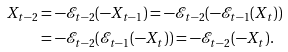Convert formula to latex. <formula><loc_0><loc_0><loc_500><loc_500>X _ { t - 2 } & = - \mathcal { E } _ { t - 2 } ( - X _ { t - 1 } ) = - \mathcal { E } _ { t - 2 } ( - \mathcal { E } _ { t - 1 } ( X _ { t } ) ) \\ & = - \mathcal { E } _ { t - 2 } ( \mathcal { E } _ { t - 1 } ( - X _ { t } ) ) = - \mathcal { E } _ { t - 2 } ( - X _ { t } ) .</formula> 